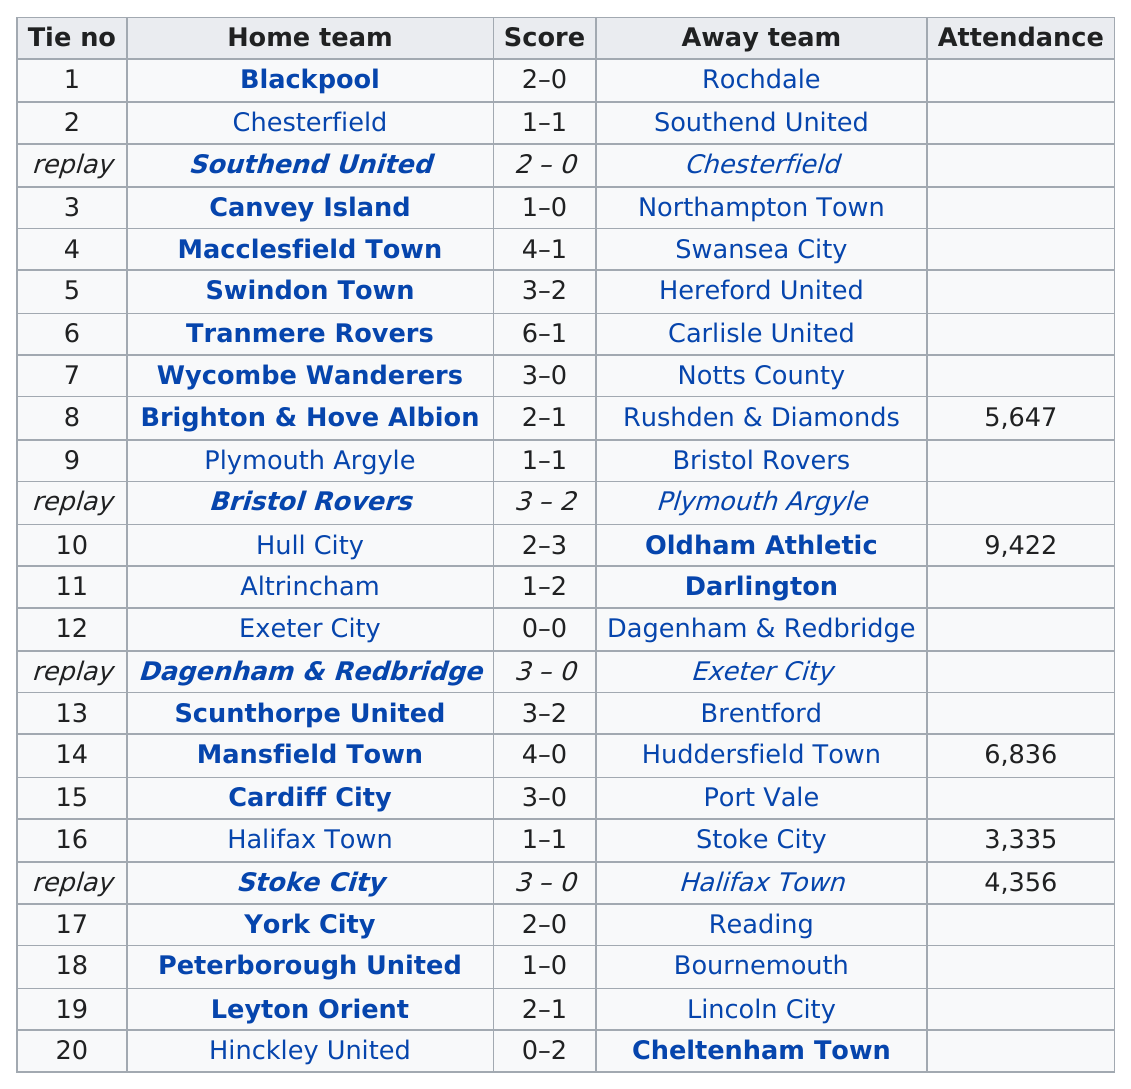Give some essential details in this illustration. Four teams played consecutive games that ended in a tie due to the games not being won by either team, resulting in the need for an additional game to determine a winner. The first replay match featured Southend United and Chesterfield. Blackpool scored a total of two points in their most recent match. Tranmere Rovers scored the most goals. The Wycombe Wanderers had more points than the Plymouth Argyle. 